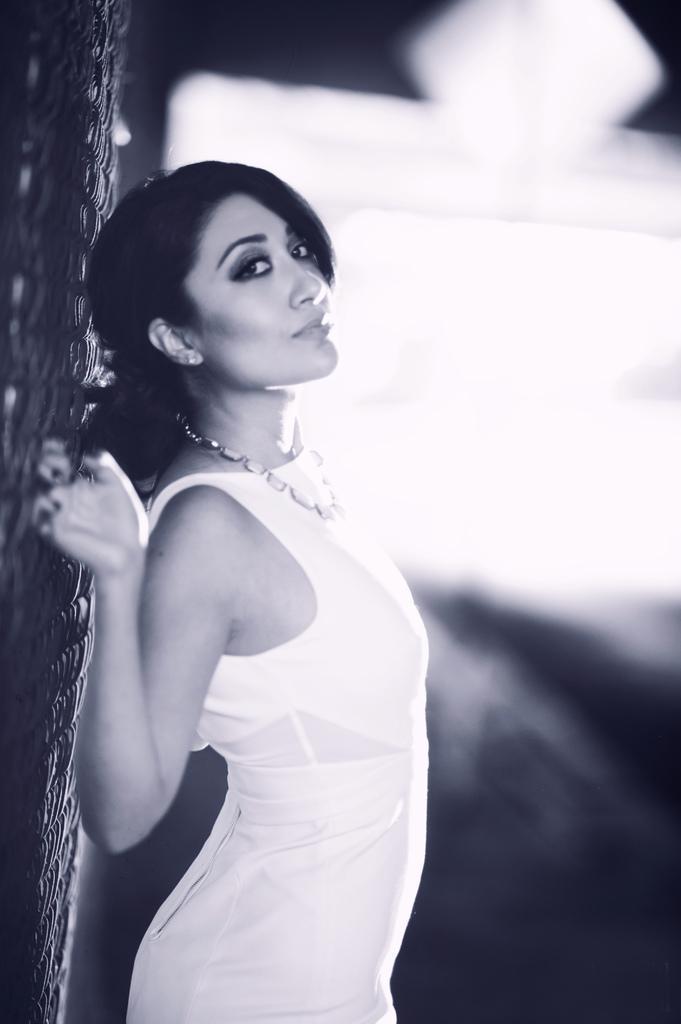Describe this image in one or two sentences. It is the black and white image in which there is a girl standing in the middle by holding the grill which is behind her. In the background it looks blurry. 